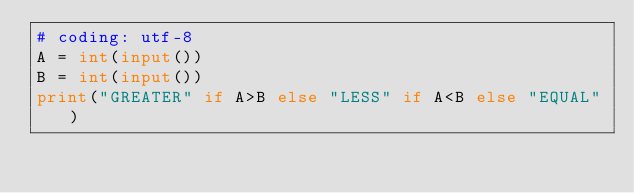Convert code to text. <code><loc_0><loc_0><loc_500><loc_500><_Python_># coding: utf-8
A = int(input())
B = int(input())
print("GREATER" if A>B else "LESS" if A<B else "EQUAL")
</code> 